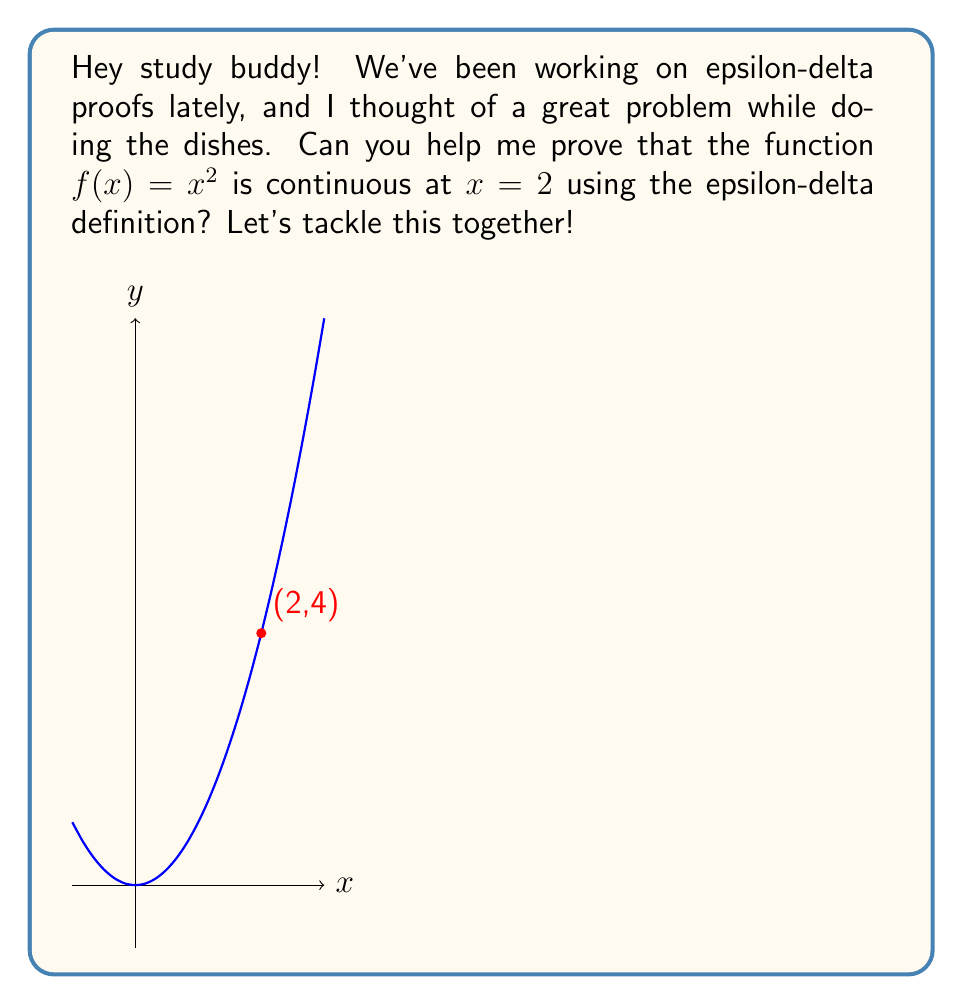Provide a solution to this math problem. Alright, let's break this down step-by-step:

1) To prove continuity at $x = 2$ using the epsilon-delta definition, we need to show that for any $\epsilon > 0$, there exists a $\delta > 0$ such that:

   If $|x - 2| < \delta$, then $|f(x) - f(2)| < \epsilon$

2) We know that $f(x) = x^2$ and $f(2) = 2^2 = 4$

3) Let's set up the inequality we need to satisfy:
   $|f(x) - f(2)| = |x^2 - 4| < \epsilon$

4) We can factor this:
   $|x^2 - 4| = |(x+2)(x-2)| < \epsilon$

5) Now, we need to relate this to $|x - 2|$. Let's assume $|x - 2| < 1$ (we'll use this later to set $\delta$). This means $1 < x < 3$, so $|x + 2| < 5$

6) Using this, we can say:
   $|(x+2)(x-2)| = |x+2||x-2| < 5|x-2|$

7) So, if we can make $5|x-2| < \epsilon$, we're done. This happens when:
   $|x-2| < \frac{\epsilon}{5}$

8) Therefore, we can choose $\delta = \min(1, \frac{\epsilon}{5})$

9) With this choice of $\delta$, whenever $|x - 2| < \delta$, we have:
   $|f(x) - f(2)| = |x^2 - 4| < 5|x-2| < 5 \cdot \frac{\epsilon}{5} = \epsilon$

This completes the proof.
Answer: $\delta = \min(1, \frac{\epsilon}{5})$ 